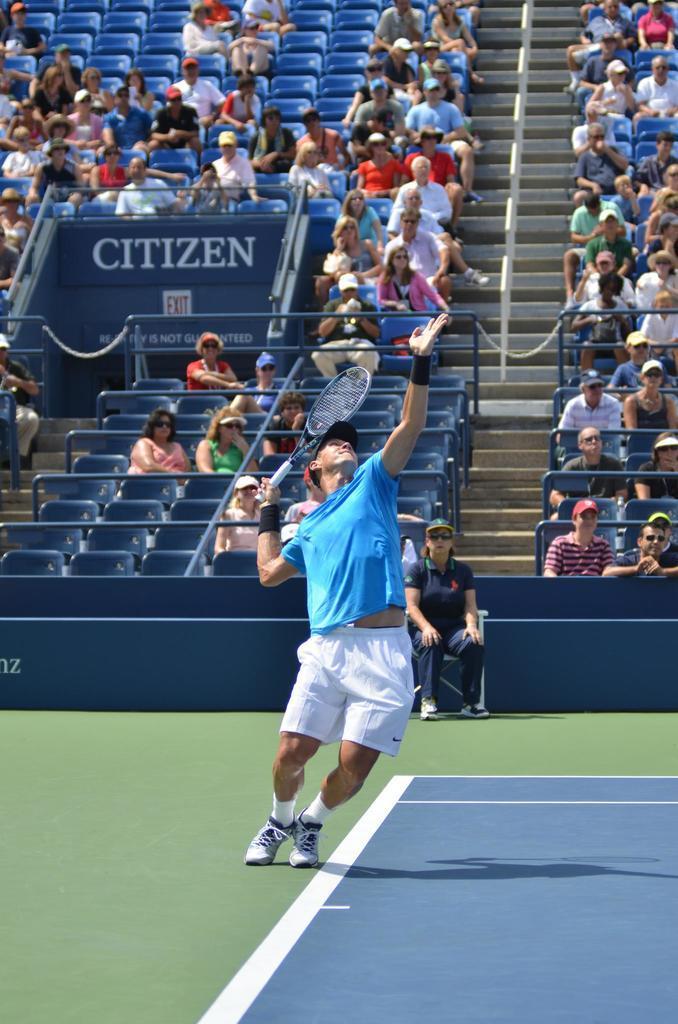Describe this image in one or two sentences. In this picture I can see few people seated on the chairs and a man playing a tennis with the help of a tennis racket in his hand and I can see another woman seated on the chair, it looks like a stadium and I can see text on the wall. 